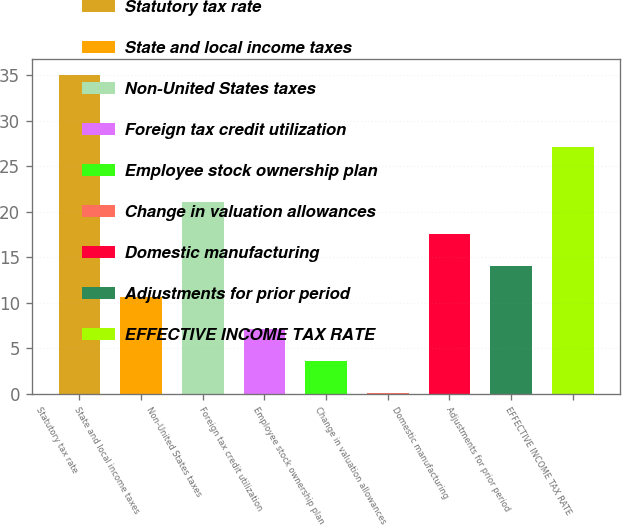<chart> <loc_0><loc_0><loc_500><loc_500><bar_chart><fcel>Statutory tax rate<fcel>State and local income taxes<fcel>Non-United States taxes<fcel>Foreign tax credit utilization<fcel>Employee stock ownership plan<fcel>Change in valuation allowances<fcel>Domestic manufacturing<fcel>Adjustments for prior period<fcel>EFFECTIVE INCOME TAX RATE<nl><fcel>35<fcel>10.57<fcel>21.04<fcel>7.08<fcel>3.59<fcel>0.1<fcel>17.55<fcel>14.06<fcel>27.1<nl></chart> 